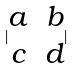Convert formula to latex. <formula><loc_0><loc_0><loc_500><loc_500>| \begin{matrix} a & b \\ c & d \end{matrix} |</formula> 